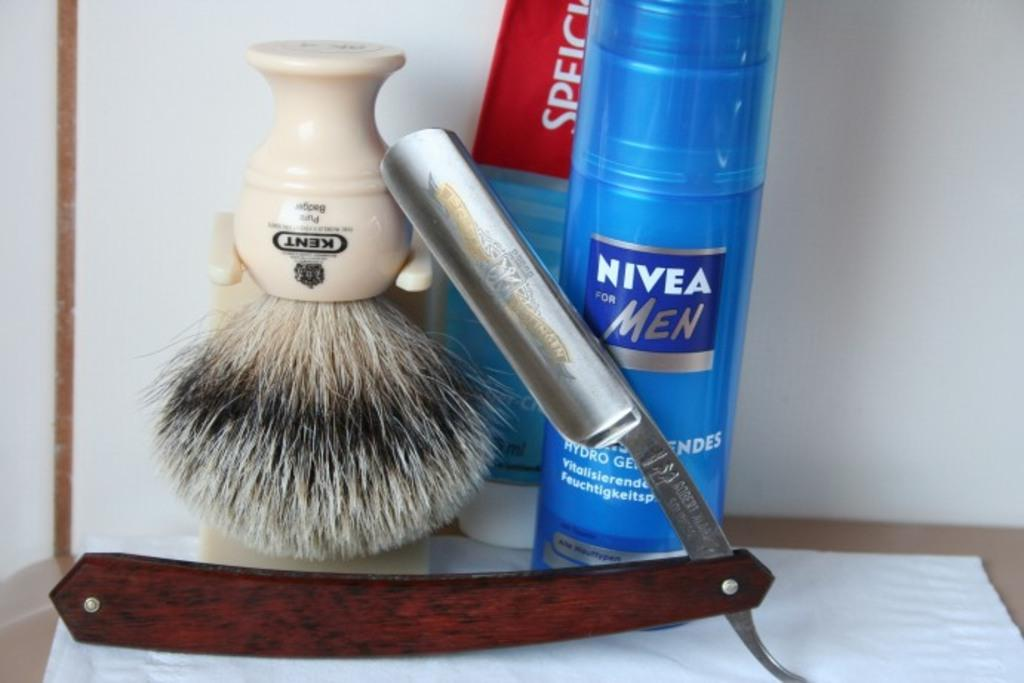<image>
Create a compact narrative representing the image presented. A razor rests against a can of Nivea for Men. 